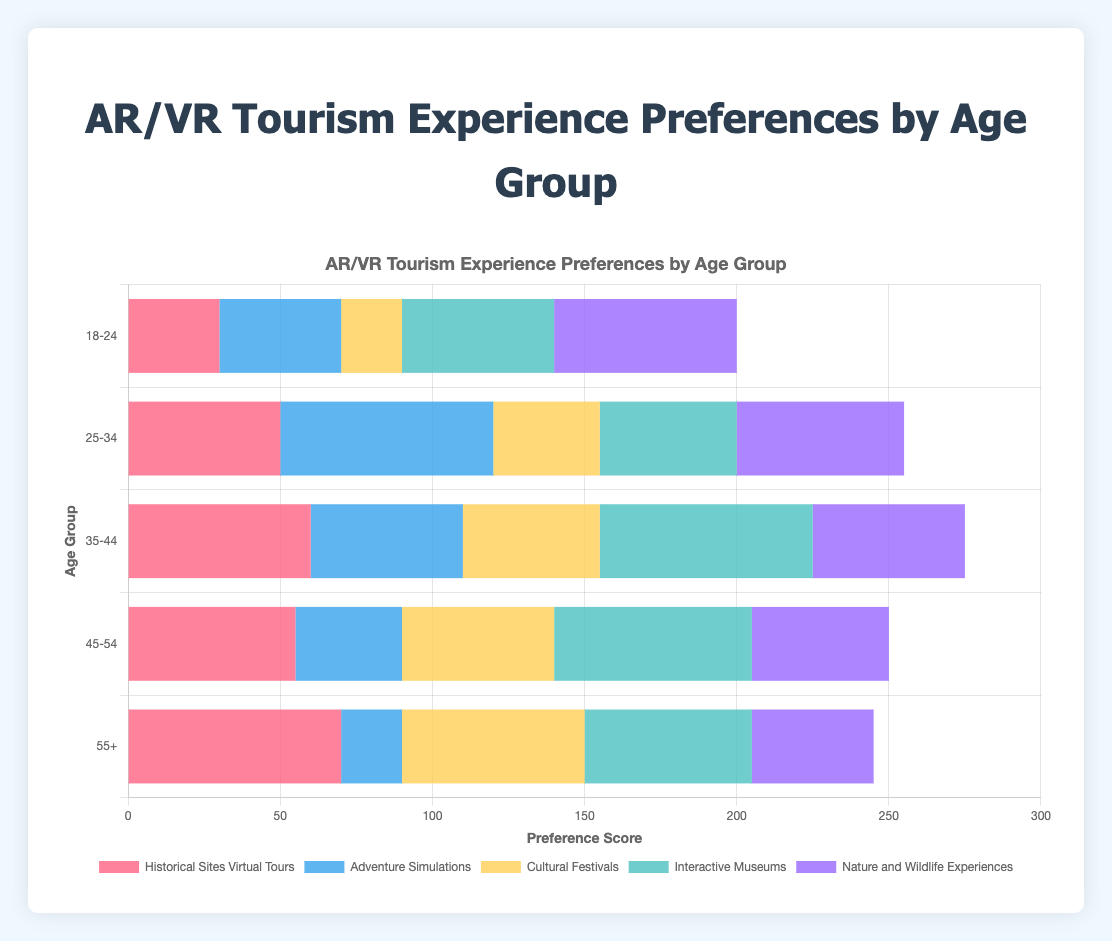What age group has the highest preference for Interactive Museums? To determine the age group with the highest preference for Interactive Museums, look at the bar representing Interactive Museums on the chart and identify the tallest bar. The age group 35-44 has the highest preference with a score of 70.
Answer: 35-44 Which AR/VR experience is least preferred by the 18-24 age group? Look at the preferences for the 18-24 age group and identify the AR/VR experience with the smallest value. Cultural Festivals is the least preferred with a score of 20.
Answer: Cultural Festivals How does the preference for Historical Sites Virtual Tours compare between the 18-24 and 55+ age groups? Compare the heights of the bars for Historical Sites Virtual Tours for both age groups. The preference score is 30 for the 18-24 group and 70 for the 55+ group. The 55+ group has a higher preference.
Answer: 55+ has a higher preference Which age group has equal scores for Cultural Festivals and Interactive Museums? Find the age group where the bars for Cultural Festivals and Interactive Museums are of equal height. The 55+ age group has an equal score of 55 for both Cultural Festivals and Interactive Museums.
Answer: 55+ What's the combined preference score for Adventure Simulations and Nature and Wildlife Experiences in the 25-34 age group? Add the scores for Adventure Simulations and Nature and Wildlife Experiences in the 25-34 age group. The scores are 70 and 55 respectively, so 70 + 55 = 125.
Answer: 125 Is the preference for Cultural Festivals higher in the 35-44 or 45-54 age group? Compare the heights of the bars for Cultural Festivals between the 35-44 and 45-54 age groups. The preference score for the 35-44 age group is 45, and for the 45-54 age group, it is 50. The 45-54 group has a higher preference.
Answer: 45-54 has a higher preference What is the average preference score for Nature and Wildlife Experiences across all age groups? Add the scores for Nature and Wildlife Experiences from all age groups and divide by the number of age groups. (60 + 55 + 50 + 45 + 40) / 5 = 50.
Answer: 50 Which experience is most preferred by the 35-44 age group? Look for the tallest bar in the 35-44 age range section. The tallest bar represents Interactive Museums with a preference score of 70.
Answer: Interactive Museums How many more points does the 55+ age group score for Historical Sites Virtual Tours compared to Adventure Simulations? Subtract the preference score for Adventure Simulations from Historical Sites Virtual Tours in the 55+ age group. 70 - 20 = 50.
Answer: 50 points In which age group is Adventure Simulations most popular? Identify the age group with the tallest bar for Adventure Simulations. The 25-34 age group has the highest score with 70 points.
Answer: 25-34 